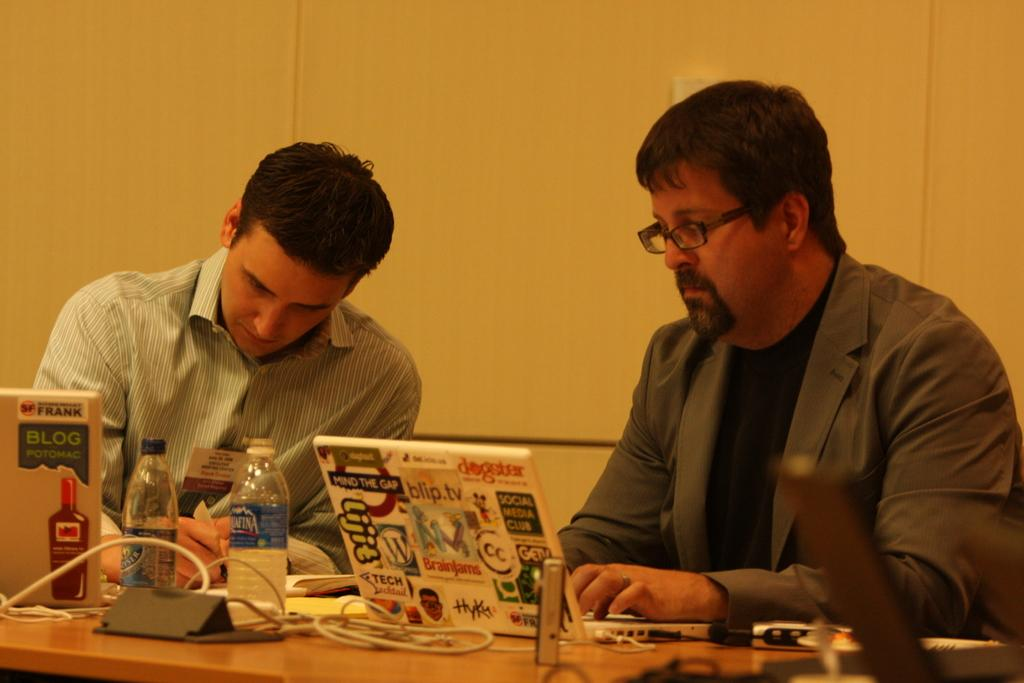How many people are in the image? There are two men in the image. What are the men doing in the image? The men are sitting in chairs. What is in front of the men? The men are in front of a table. What objects are on the table in front of the men? The men have laptops in front of them. What else can be seen related to the laptops? There are wires associated with the laptops. What else is visible in the image? There are bottles visible in the image. What type of eye is visible on the throne in the image? There is no throne or eye present in the image. What kind of doll is sitting on the lap of one of the men in the image? There is no doll present in the image; the men are sitting in chairs with laptops in front of them. 